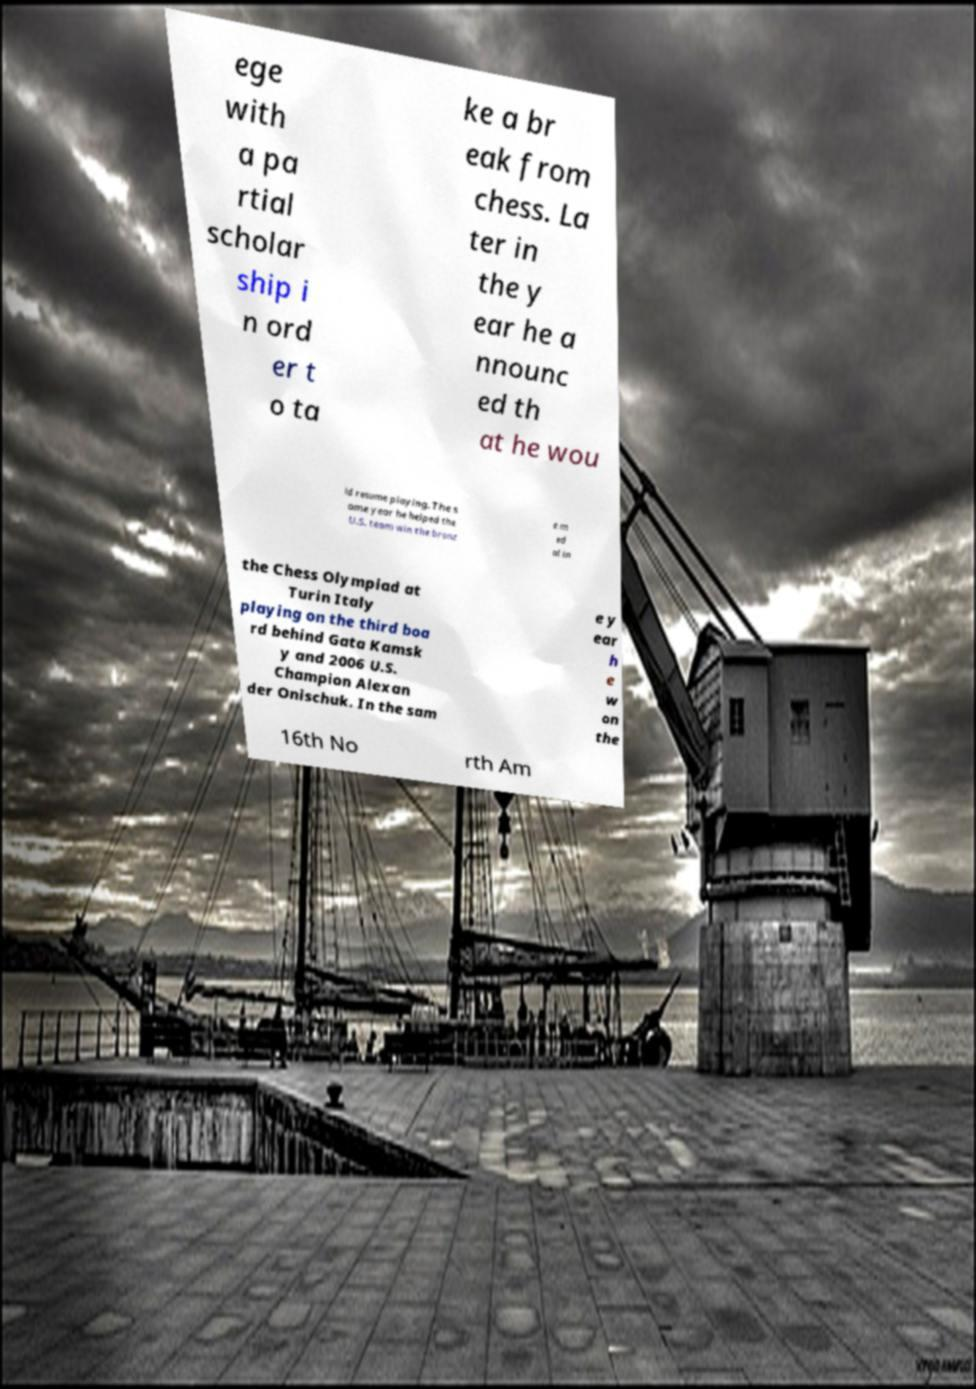Could you extract and type out the text from this image? ege with a pa rtial scholar ship i n ord er t o ta ke a br eak from chess. La ter in the y ear he a nnounc ed th at he wou ld resume playing. The s ame year he helped the U.S. team win the bronz e m ed al in the Chess Olympiad at Turin Italy playing on the third boa rd behind Gata Kamsk y and 2006 U.S. Champion Alexan der Onischuk. In the sam e y ear h e w on the 16th No rth Am 